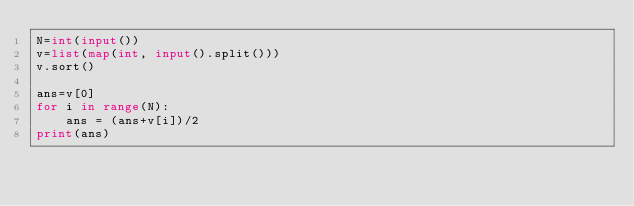<code> <loc_0><loc_0><loc_500><loc_500><_Python_>N=int(input())
v=list(map(int, input().split()))
v.sort()

ans=v[0]
for i in range(N):
    ans = (ans+v[i])/2
print(ans)</code> 